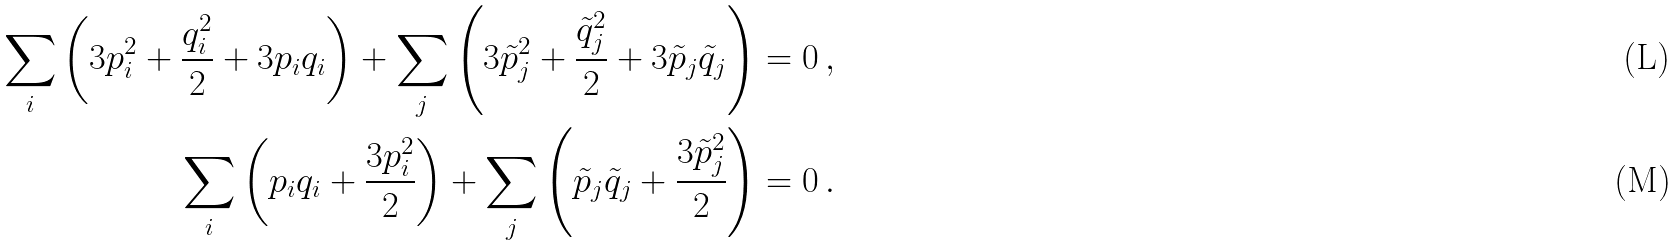<formula> <loc_0><loc_0><loc_500><loc_500>\sum _ { i } \left ( 3 p _ { i } ^ { 2 } + \frac { q _ { i } ^ { 2 } } { 2 } + 3 p _ { i } q _ { i } \right ) + \sum _ { j } \left ( 3 \tilde { p } _ { j } ^ { 2 } + \frac { \tilde { q } _ { j } ^ { 2 } } { 2 } + 3 \tilde { p } _ { j } \tilde { q } _ { j } \right ) = 0 \, , \\ \quad \sum _ { i } \left ( p _ { i } q _ { i } + \frac { 3 p _ { i } ^ { 2 } } { 2 } \right ) + \sum _ { j } \left ( \tilde { p } _ { j } \tilde { q } _ { j } + \frac { 3 \tilde { p } _ { j } ^ { 2 } } { 2 } \right ) = 0 \, .</formula> 